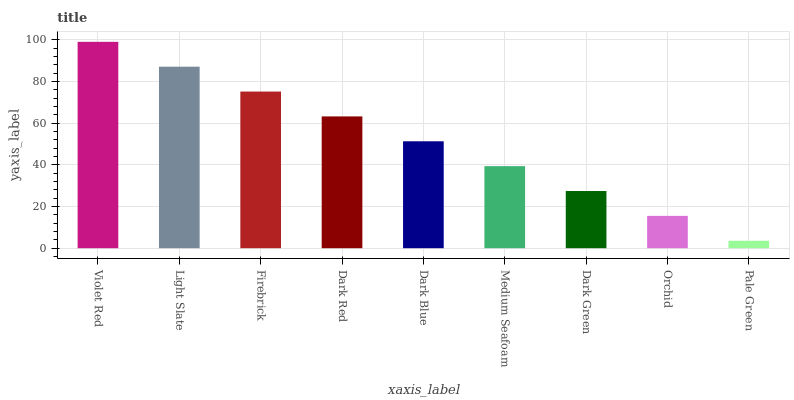Is Light Slate the minimum?
Answer yes or no. No. Is Light Slate the maximum?
Answer yes or no. No. Is Violet Red greater than Light Slate?
Answer yes or no. Yes. Is Light Slate less than Violet Red?
Answer yes or no. Yes. Is Light Slate greater than Violet Red?
Answer yes or no. No. Is Violet Red less than Light Slate?
Answer yes or no. No. Is Dark Blue the high median?
Answer yes or no. Yes. Is Dark Blue the low median?
Answer yes or no. Yes. Is Light Slate the high median?
Answer yes or no. No. Is Pale Green the low median?
Answer yes or no. No. 